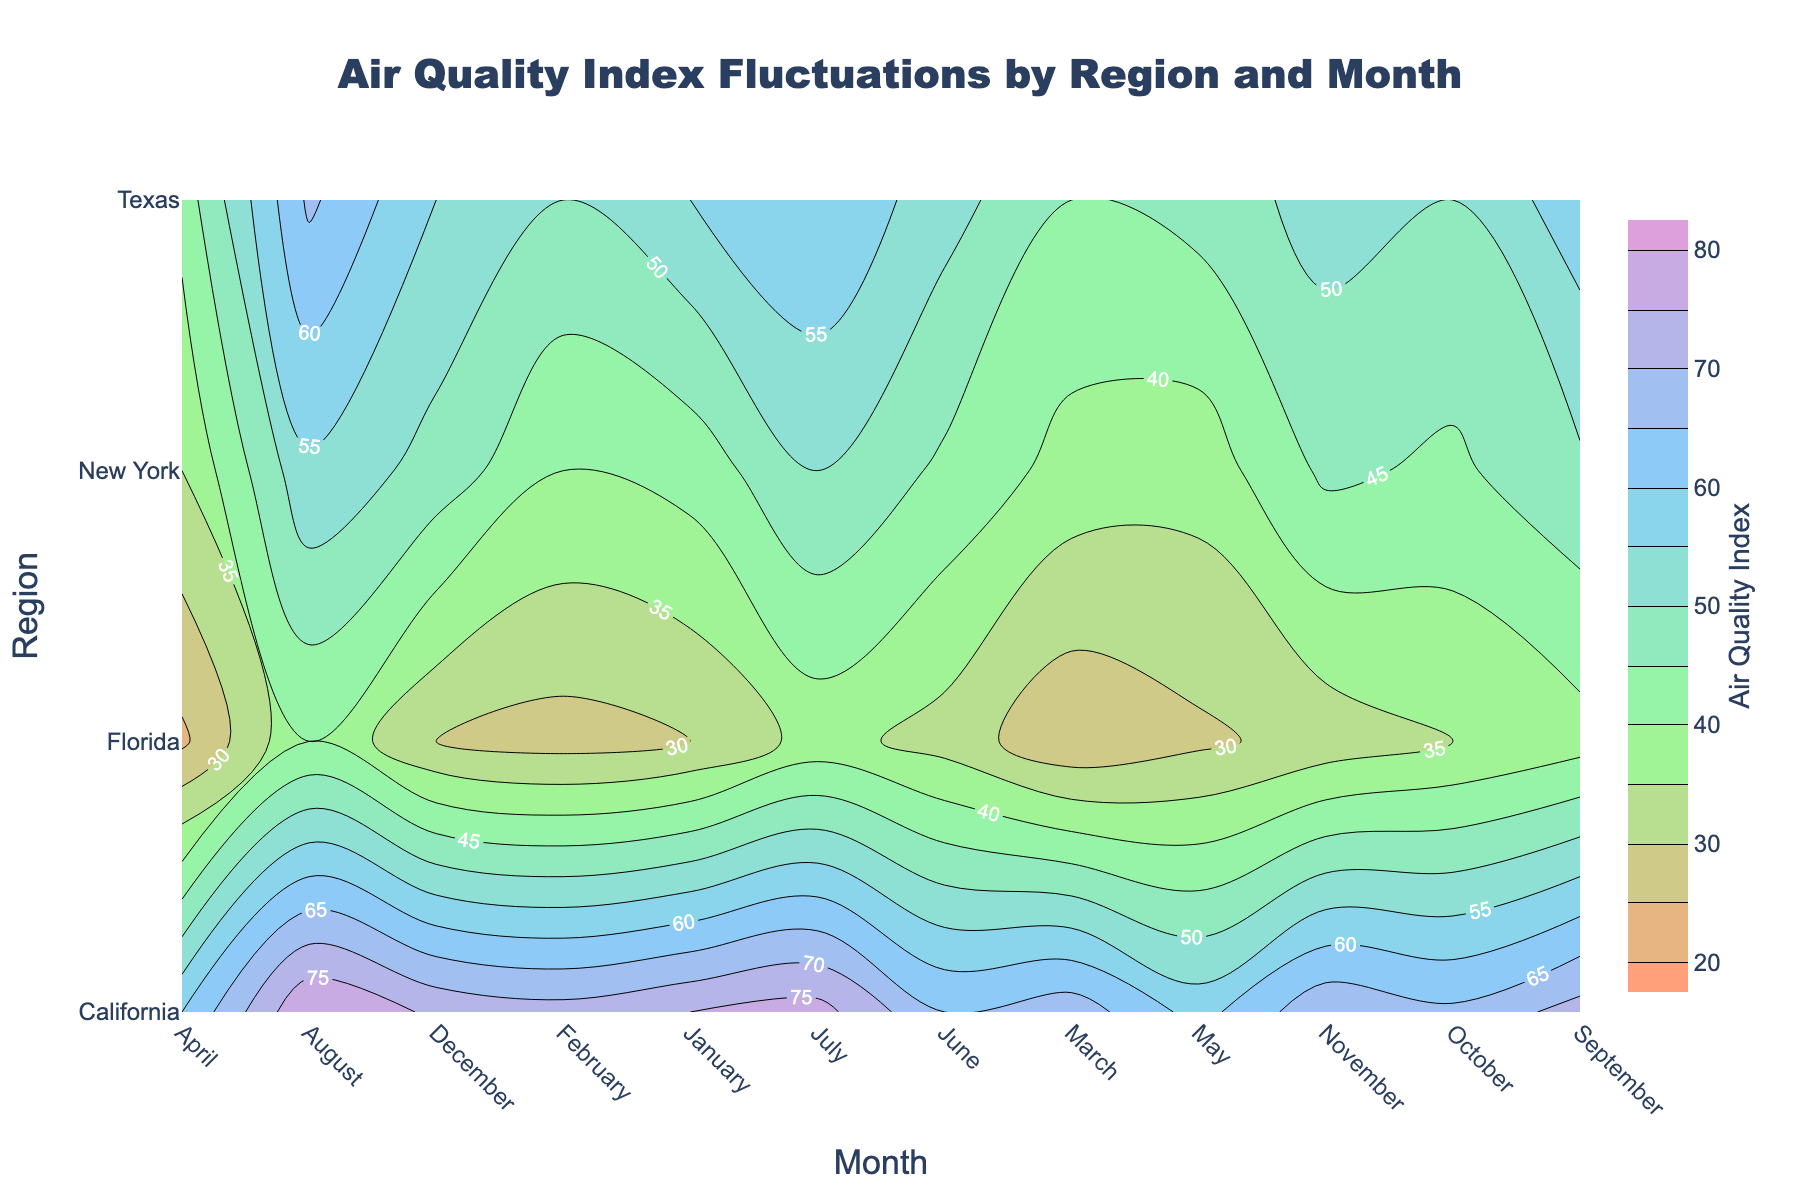What is the title of the plot? The title is located at the top center of the plot. It summarizes what the plot is displaying, which is about the Air Quality Index across various regions and months.
Answer: Air Quality Index Fluctuations by Region and Month Which month and region combination has the highest Air Quality Index? To find this, look for the highest contour value on the plot. Here, it shows up as 80 in August for California.
Answer: California in August What are the three regions with the most similar Air Quality Index in July? Look for the values for July across different regions and compare them. California has an index of 77, Texas has 60, New York has 50, and Florida has 37. Texas and New York are closest.
Answer: Texas, New York, and Florida How does the Air Quality Index trend in California from January to December? Follow the contour values for California from January to December. The trend increases slightly from January to July, peaks in August, and then decreases again towards December.
Answer: It shows an increase, peaks in August, and then decreases Which region has the most significant change in Air Quality Index throughout the year? Compare the differences in the highest and lowest values within each region from January to December. California varies from 58 to 80, Texas from 42 to 66, New York from 35 to 54, and Florida from 24 to 40. California has the largest range.
Answer: California Between February and April, which region shows the lowest Air Quality Index in April? Compare the values in April for different regions. California has 60, Texas has 42, New York has 35, and Florida has 24. Florida is the lowest.
Answer: Florida Is the Air Quality Index in Texas higher in January or October? Compare the values for Texas in January (55) and October (50). January is higher.
Answer: January Which region shows the highest Air Quality Index in the middle of the year (June)? Compare the June values across regions: California (65), Texas (52), New York (44), and Florida (33). California is the highest.
Answer: California Does New York have a higher Air Quality Index in January or December? Compare the values for January (42) and December (48) in New York. December is higher.
Answer: December 